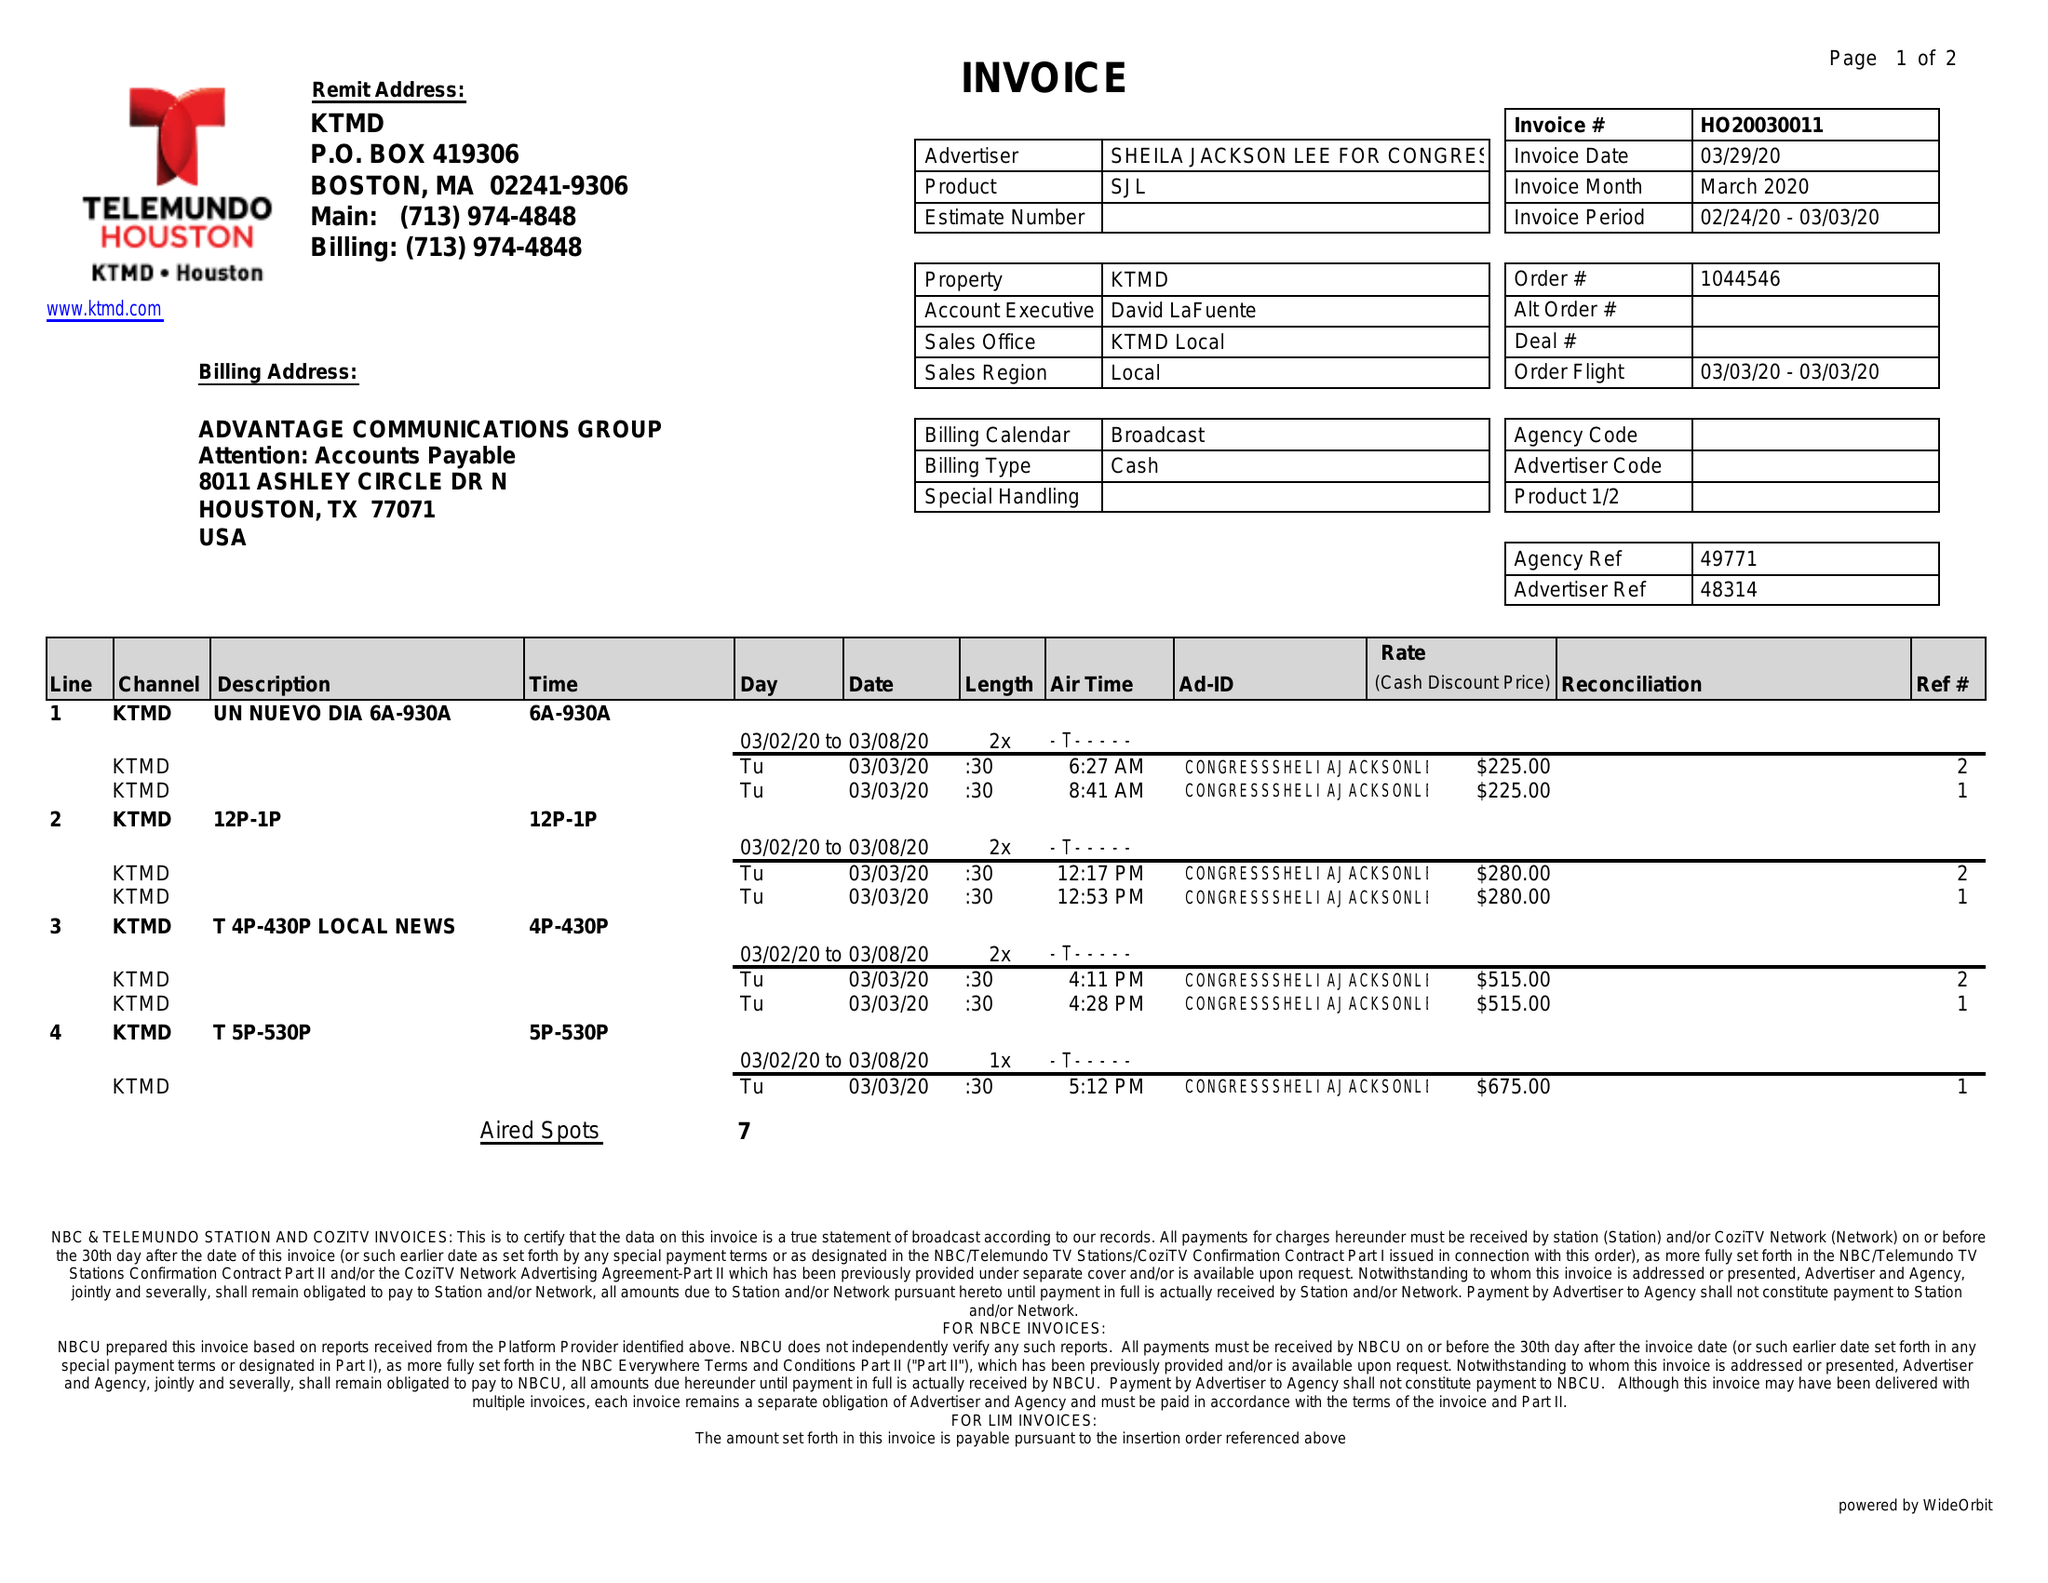What is the value for the flight_from?
Answer the question using a single word or phrase. 03/03/20 